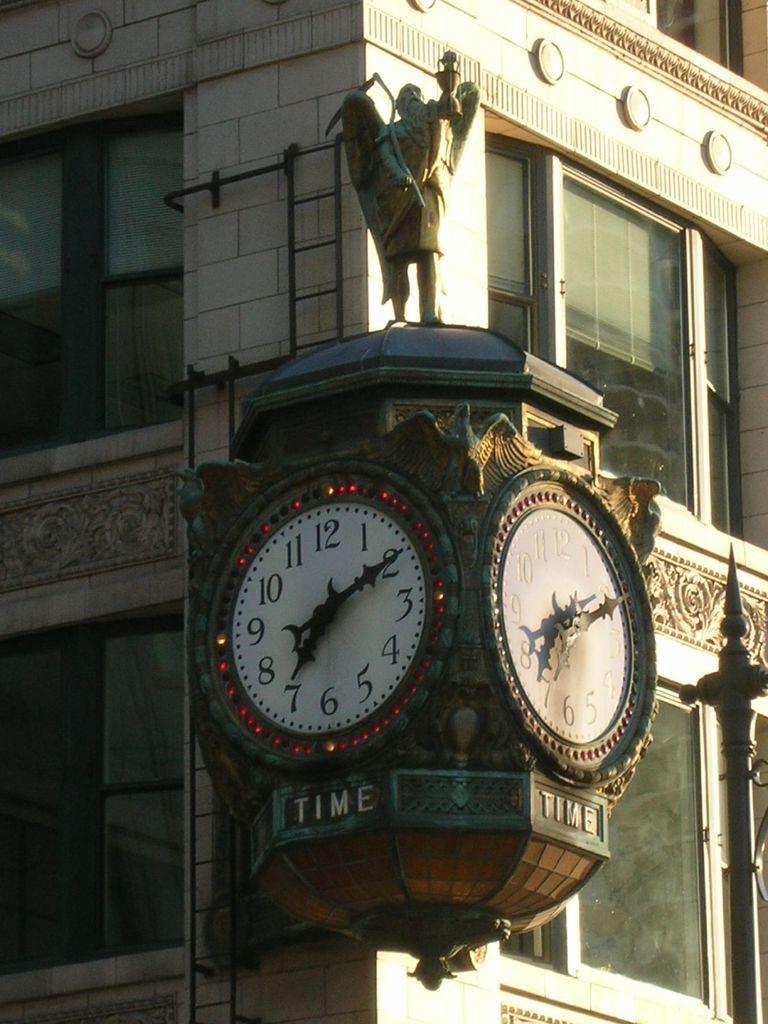What time you see this clock?
Your answer should be very brief. 7:10. 